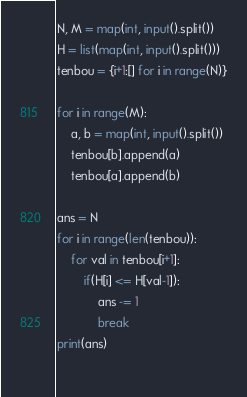<code> <loc_0><loc_0><loc_500><loc_500><_Python_>N, M = map(int, input().split())
H = list(map(int, input().split()))
tenbou = {i+1:[] for i in range(N)}

for i in range(M):
    a, b = map(int, input().split())
    tenbou[b].append(a)
    tenbou[a].append(b)

ans = N
for i in range(len(tenbou)):
    for val in tenbou[i+1]:
        if(H[i] <= H[val-1]):
            ans -= 1
            break
print(ans)
    </code> 